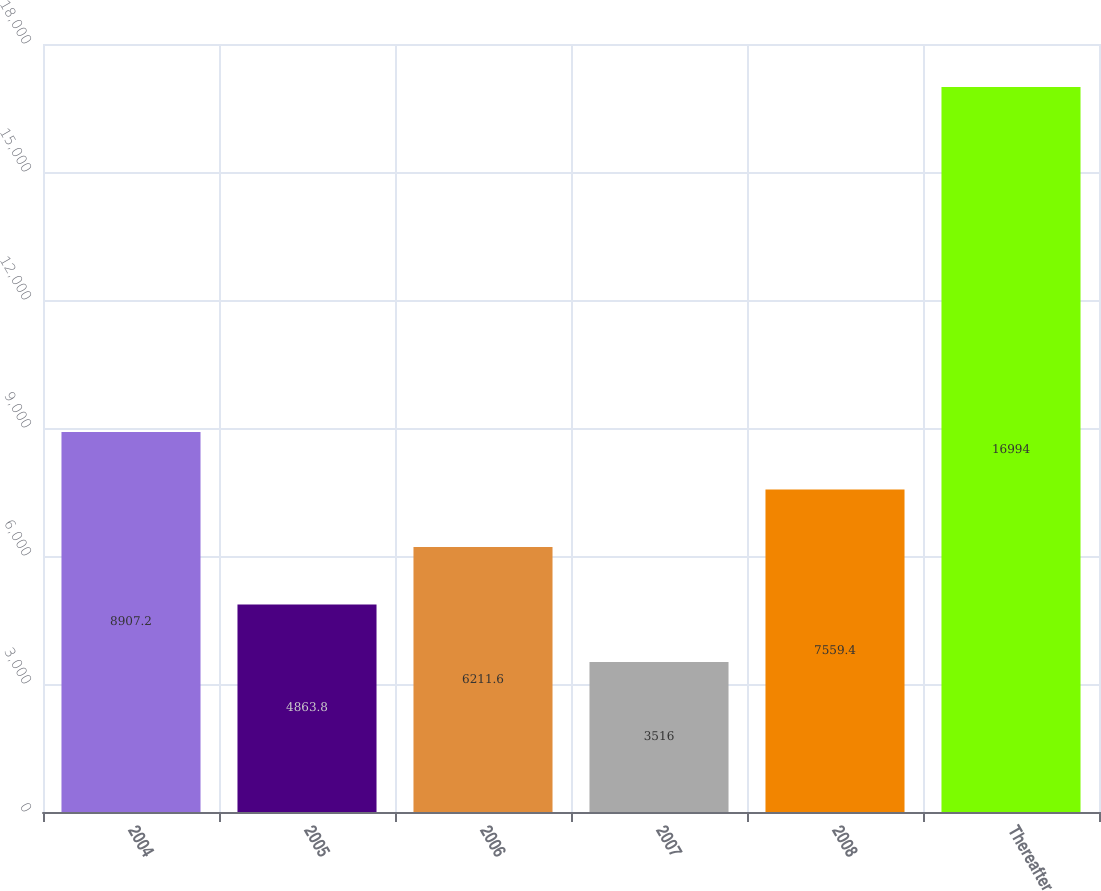<chart> <loc_0><loc_0><loc_500><loc_500><bar_chart><fcel>2004<fcel>2005<fcel>2006<fcel>2007<fcel>2008<fcel>Thereafter<nl><fcel>8907.2<fcel>4863.8<fcel>6211.6<fcel>3516<fcel>7559.4<fcel>16994<nl></chart> 